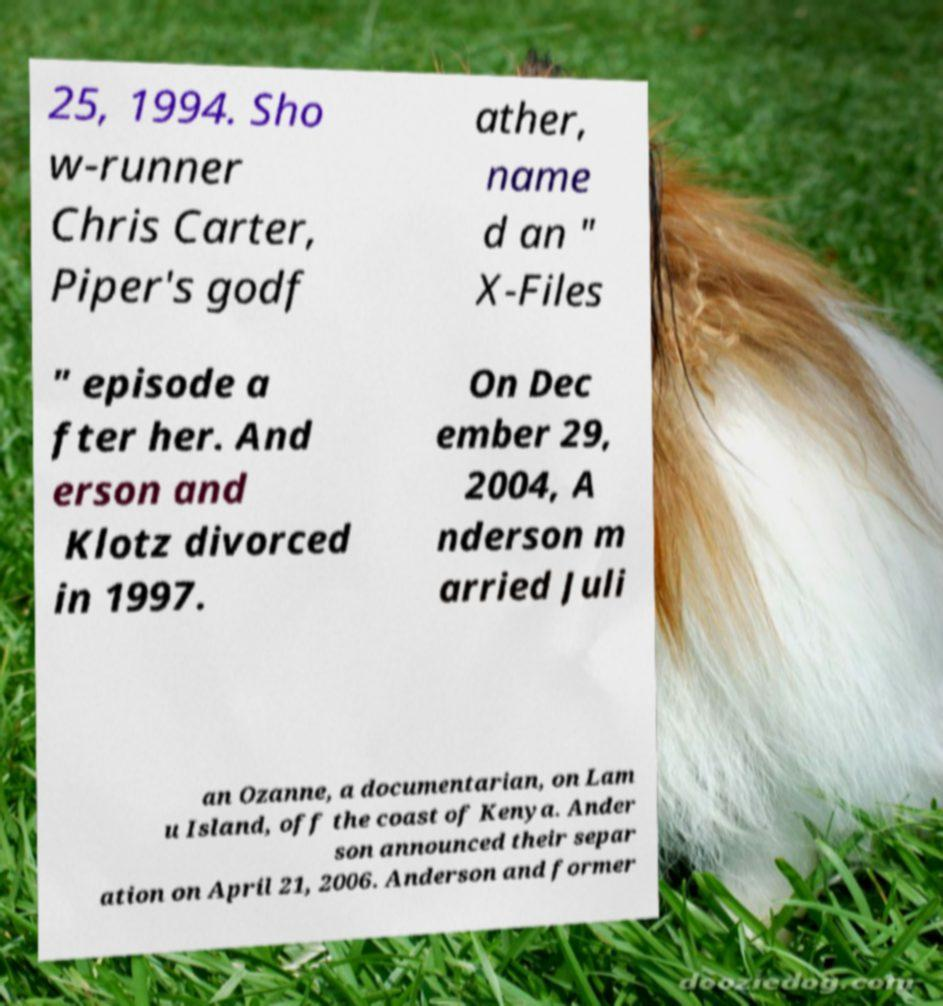There's text embedded in this image that I need extracted. Can you transcribe it verbatim? 25, 1994. Sho w-runner Chris Carter, Piper's godf ather, name d an " X-Files " episode a fter her. And erson and Klotz divorced in 1997. On Dec ember 29, 2004, A nderson m arried Juli an Ozanne, a documentarian, on Lam u Island, off the coast of Kenya. Ander son announced their separ ation on April 21, 2006. Anderson and former 